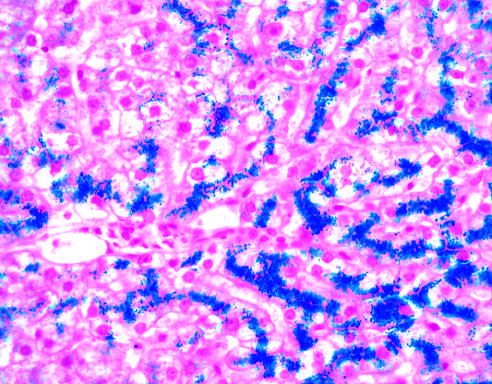how is the parenchymal architecture?
Answer the question using a single word or phrase. Normal at this stage of disease 